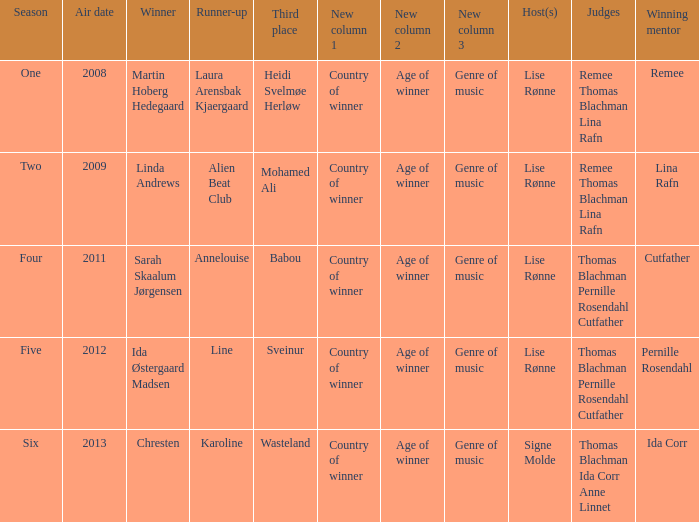Who won third place in season four? Babou. 